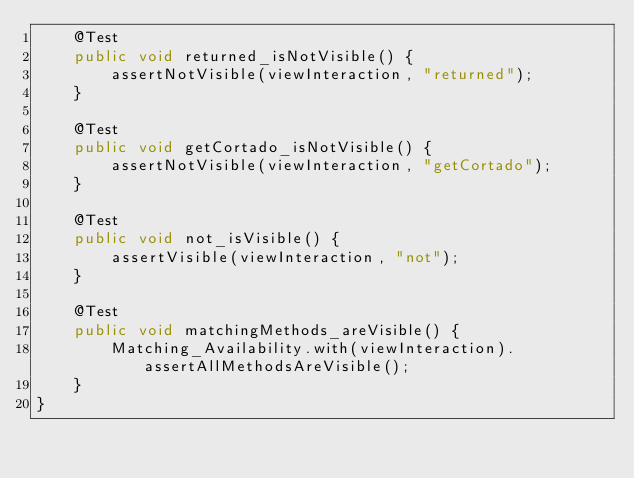Convert code to text. <code><loc_0><loc_0><loc_500><loc_500><_Java_>    @Test
    public void returned_isNotVisible() {
        assertNotVisible(viewInteraction, "returned");
    }

    @Test
    public void getCortado_isNotVisible() {
        assertNotVisible(viewInteraction, "getCortado");
    }

    @Test
    public void not_isVisible() {
        assertVisible(viewInteraction, "not");
    }

    @Test
    public void matchingMethods_areVisible() {
        Matching_Availability.with(viewInteraction).assertAllMethodsAreVisible();
    }
}
</code> 